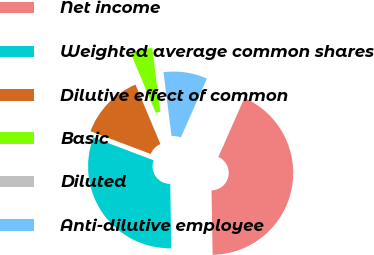Convert chart to OTSL. <chart><loc_0><loc_0><loc_500><loc_500><pie_chart><fcel>Net income<fcel>Weighted average common shares<fcel>Dilutive effect of common<fcel>Basic<fcel>Diluted<fcel>Anti-dilutive employee<nl><fcel>43.13%<fcel>31.0%<fcel>12.94%<fcel>4.31%<fcel>0.0%<fcel>8.63%<nl></chart> 